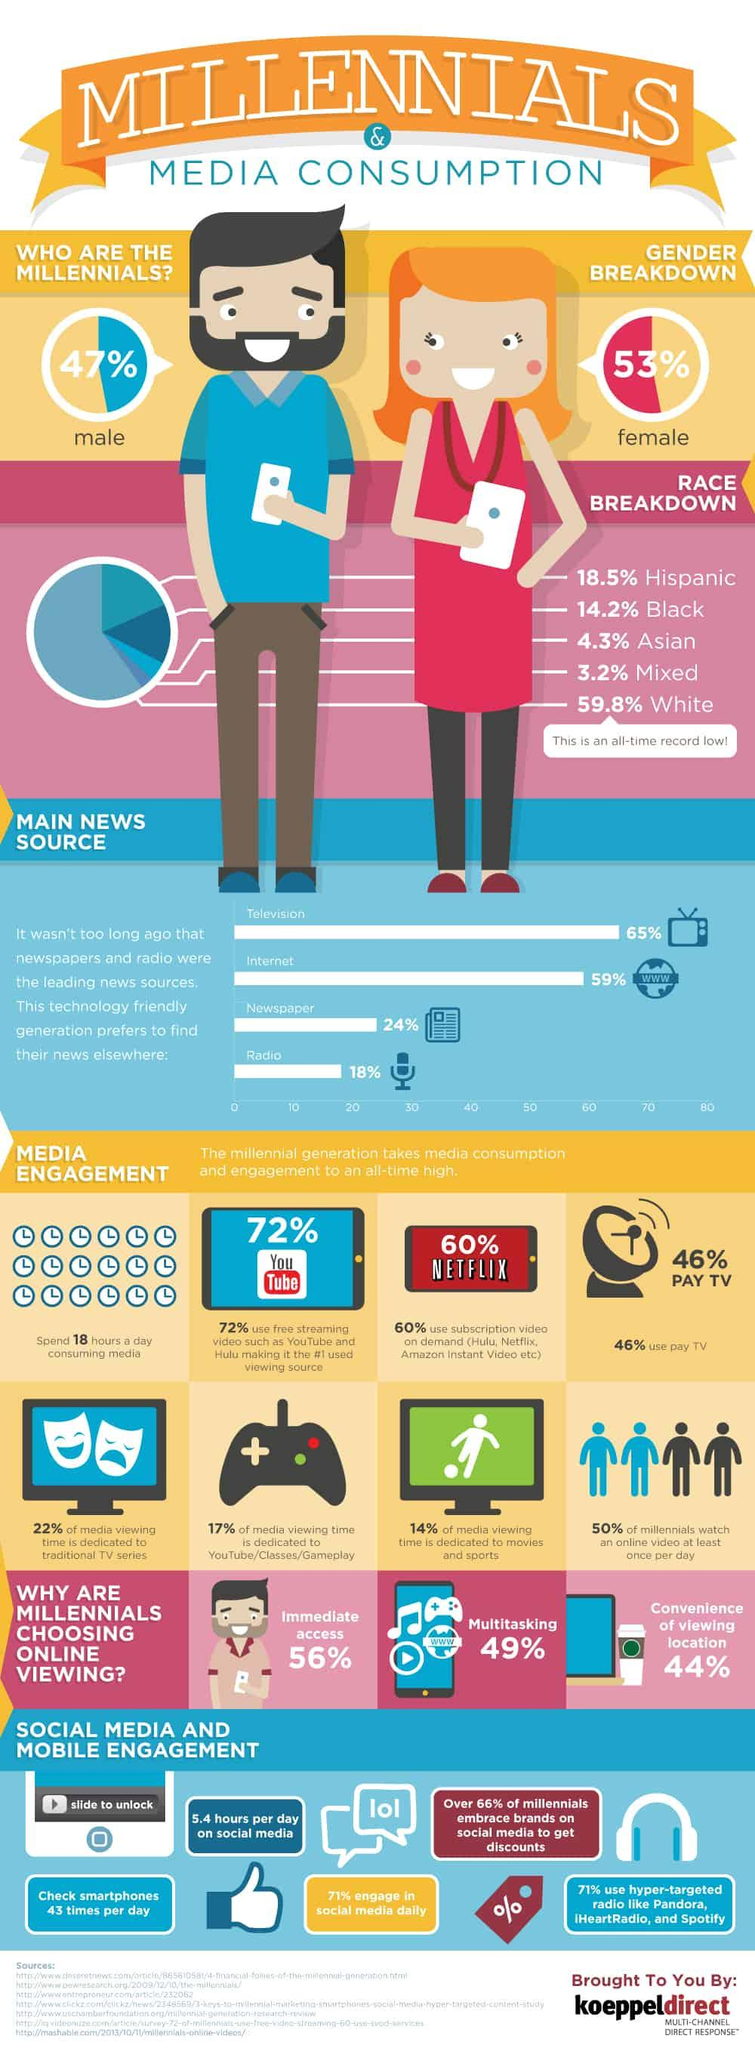Draw attention to some important aspects in this diagram. According to a recent survey, 54% of millennials in the U.S. do not use pay TV. According to a recent survey, approximately 29% of millennials in the United States do not engage in social media activities on a daily basis. The majority of millennials belong to the ethnic group of white people. The majority of millennials in the U.S. prefer online viewing because they value immediate access. Approximately 14.2% of millennials in the United States are African Americans. 